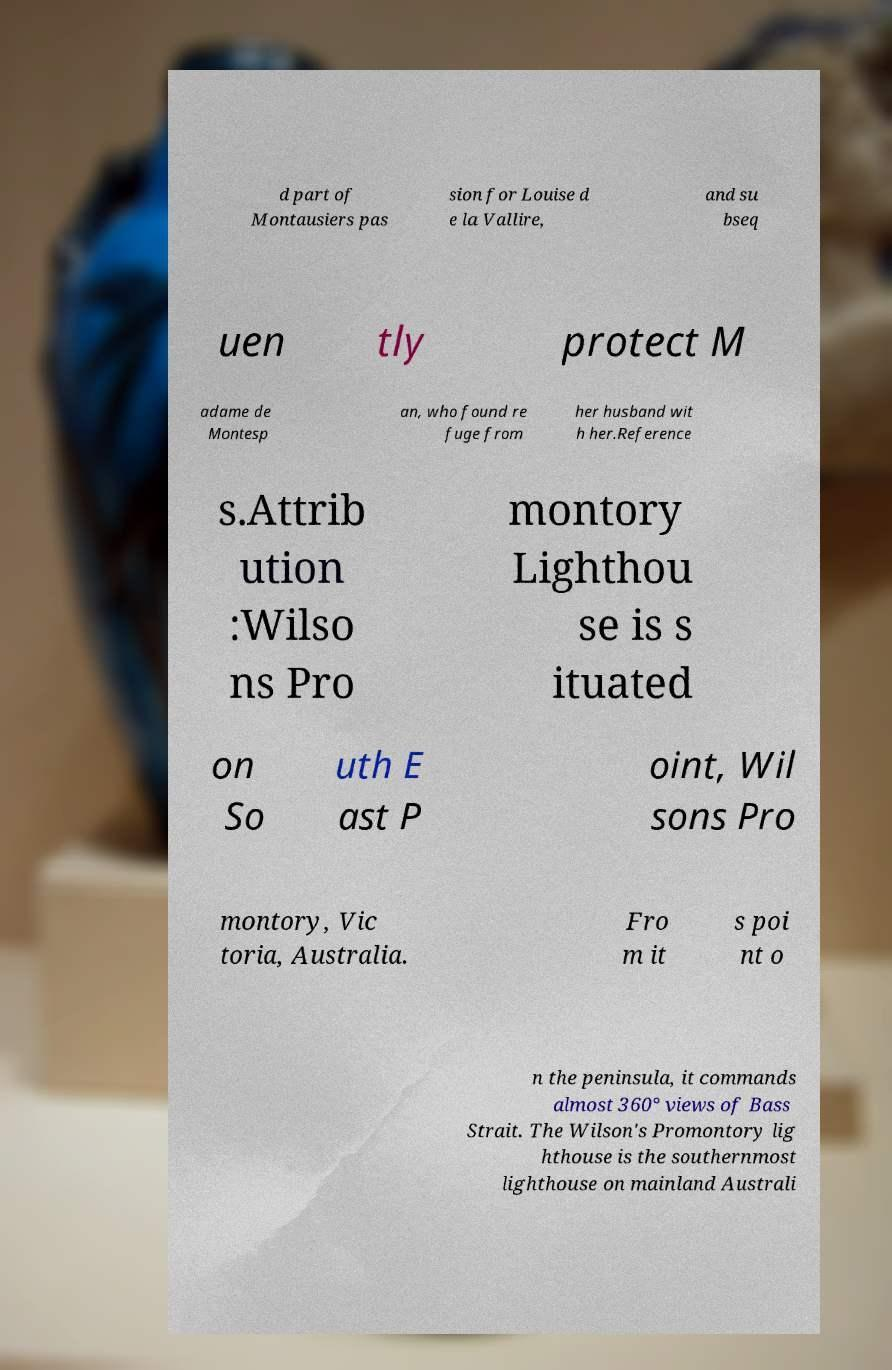For documentation purposes, I need the text within this image transcribed. Could you provide that? d part of Montausiers pas sion for Louise d e la Vallire, and su bseq uen tly protect M adame de Montesp an, who found re fuge from her husband wit h her.Reference s.Attrib ution :Wilso ns Pro montory Lighthou se is s ituated on So uth E ast P oint, Wil sons Pro montory, Vic toria, Australia. Fro m it s poi nt o n the peninsula, it commands almost 360° views of Bass Strait. The Wilson's Promontory lig hthouse is the southernmost lighthouse on mainland Australi 